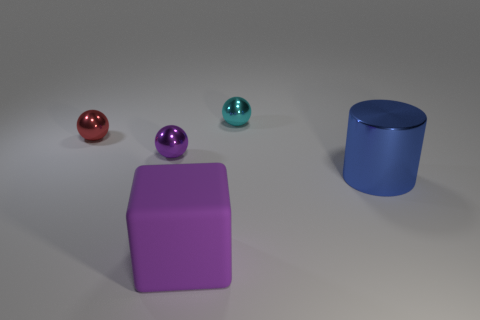How many other things are there of the same color as the matte block?
Keep it short and to the point. 1. What number of other things are there of the same material as the big purple cube
Offer a terse response. 0. There is a cyan metallic thing; is its size the same as the purple thing that is behind the blue metal thing?
Provide a succinct answer. Yes. What is the color of the matte thing?
Your answer should be very brief. Purple. What is the shape of the large object that is left of the large object behind the matte block right of the tiny red thing?
Offer a terse response. Cube. The thing to the right of the metallic sphere on the right side of the block is made of what material?
Your answer should be very brief. Metal. The small red thing that is made of the same material as the big blue thing is what shape?
Offer a very short reply. Sphere. Is there anything else that has the same shape as the large metal object?
Give a very brief answer. No. What number of metal balls are on the right side of the purple rubber object?
Your answer should be compact. 1. Is there a tiny cyan metal cube?
Offer a terse response. No. 